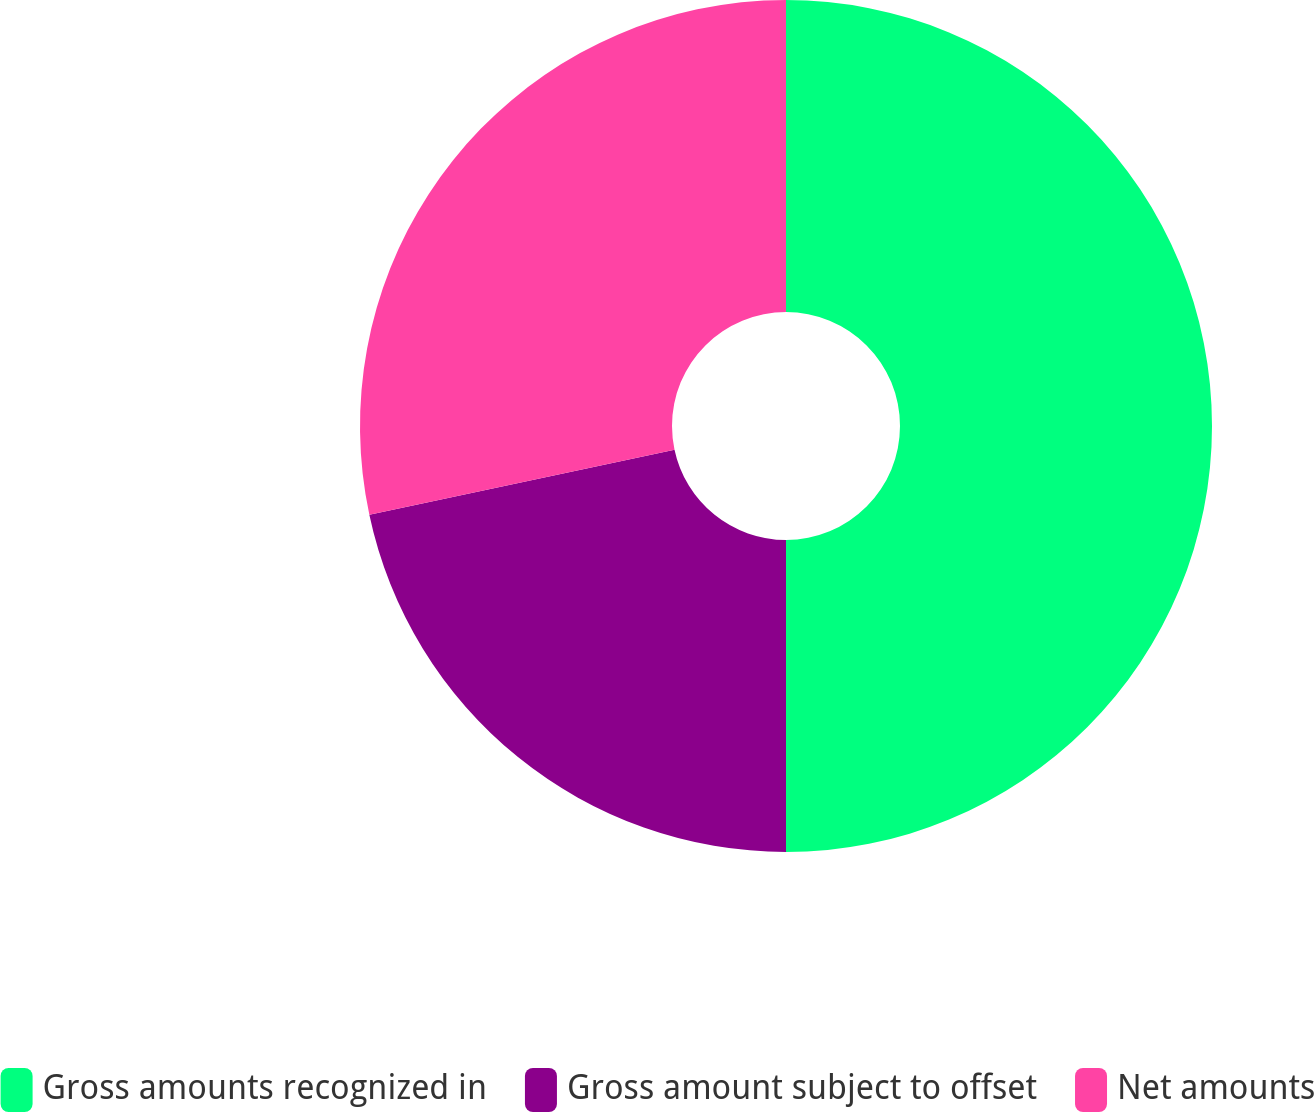Convert chart to OTSL. <chart><loc_0><loc_0><loc_500><loc_500><pie_chart><fcel>Gross amounts recognized in<fcel>Gross amount subject to offset<fcel>Net amounts<nl><fcel>50.0%<fcel>21.66%<fcel>28.34%<nl></chart> 